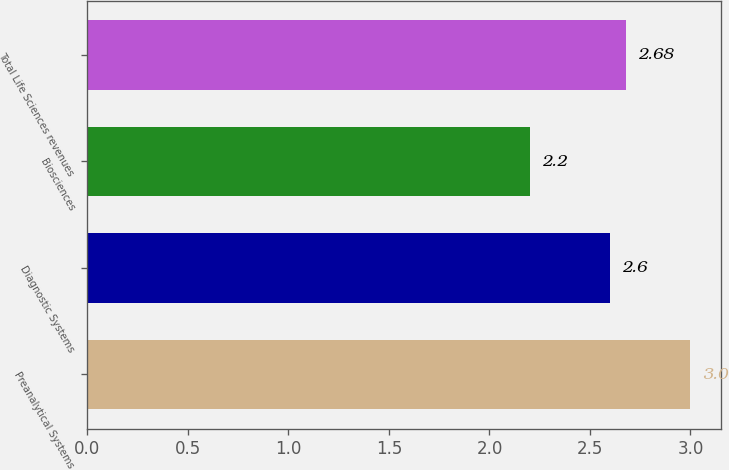<chart> <loc_0><loc_0><loc_500><loc_500><bar_chart><fcel>Preanalytical Systems<fcel>Diagnostic Systems<fcel>Biosciences<fcel>Total Life Sciences revenues<nl><fcel>3<fcel>2.6<fcel>2.2<fcel>2.68<nl></chart> 